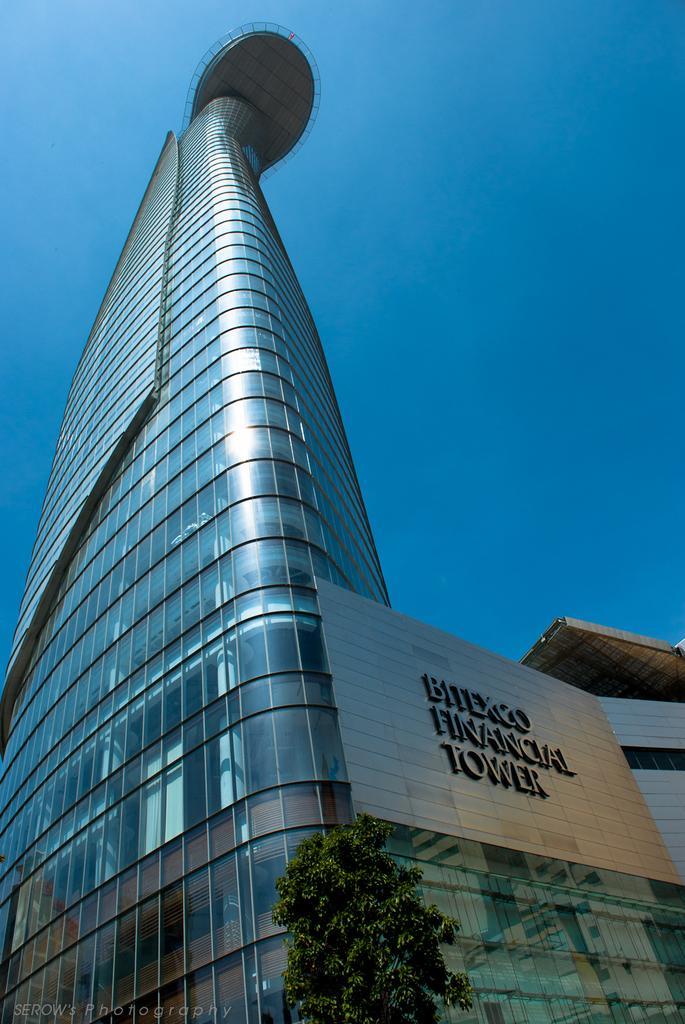In one or two sentences, can you explain what this image depicts? In this image I can see the tree in green color, background I can see the glass building and the sky is in blue color. 